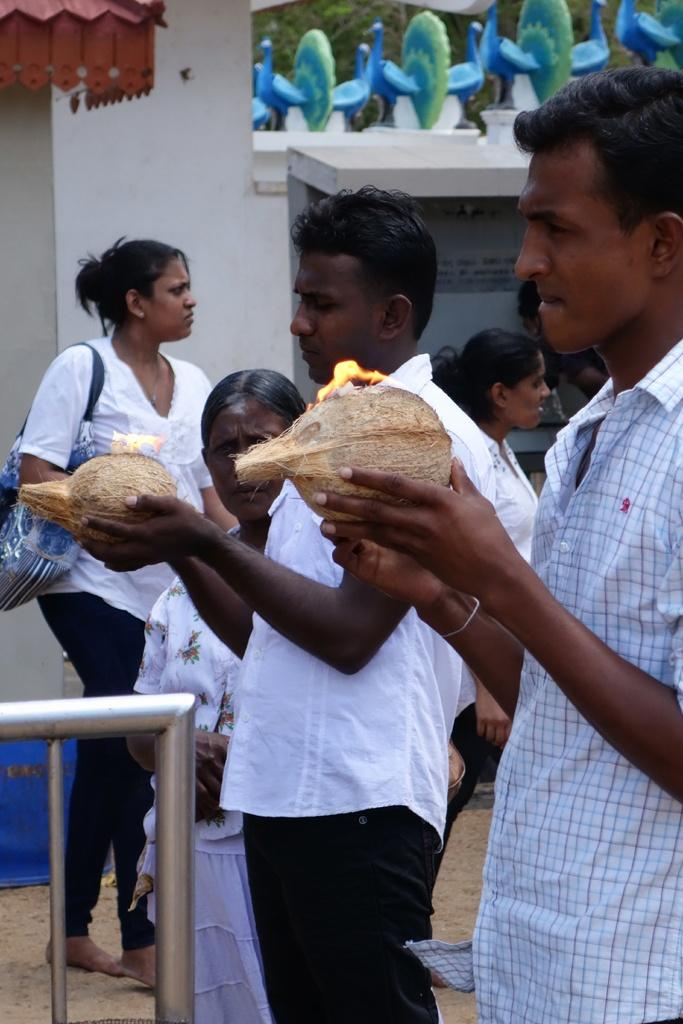How many people can be seen in the image? There are people in the image, but the exact number is not specified. What are the men holding in the image? Two men are holding coconuts with lame in the image. What is the woman carrying in the image? A woman is carrying a bag in the image. What objects can be seen in the image that resemble long, thin bars? There are rods visible in the image. What can be seen in the background of the image? There is a wall and peacocks in the background of the image. What type of loaf is being used to hold the glass in the image? There is no loaf or glass present in the image. Can you describe the collar on the peacock in the image? Peacocks do not have collars, and there is no mention of a collar in the image. 